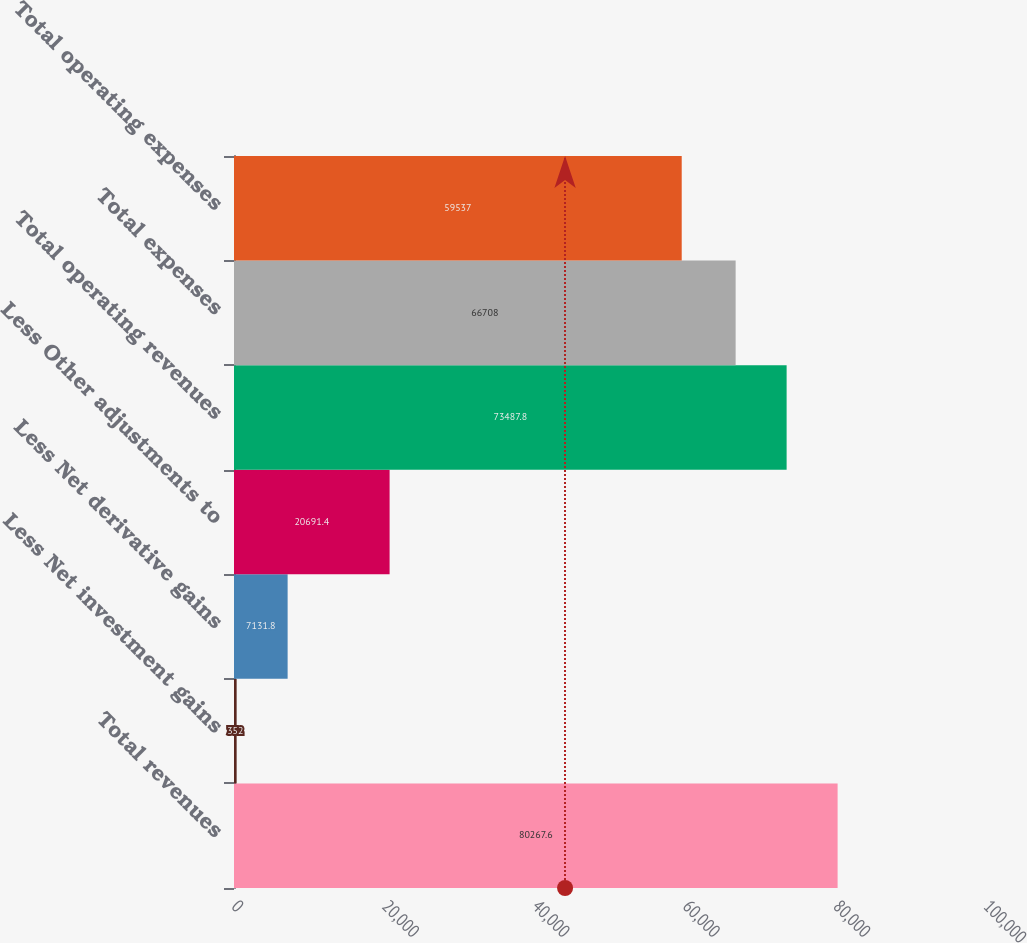Convert chart to OTSL. <chart><loc_0><loc_0><loc_500><loc_500><bar_chart><fcel>Total revenues<fcel>Less Net investment gains<fcel>Less Net derivative gains<fcel>Less Other adjustments to<fcel>Total operating revenues<fcel>Total expenses<fcel>Total operating expenses<nl><fcel>80267.6<fcel>352<fcel>7131.8<fcel>20691.4<fcel>73487.8<fcel>66708<fcel>59537<nl></chart> 